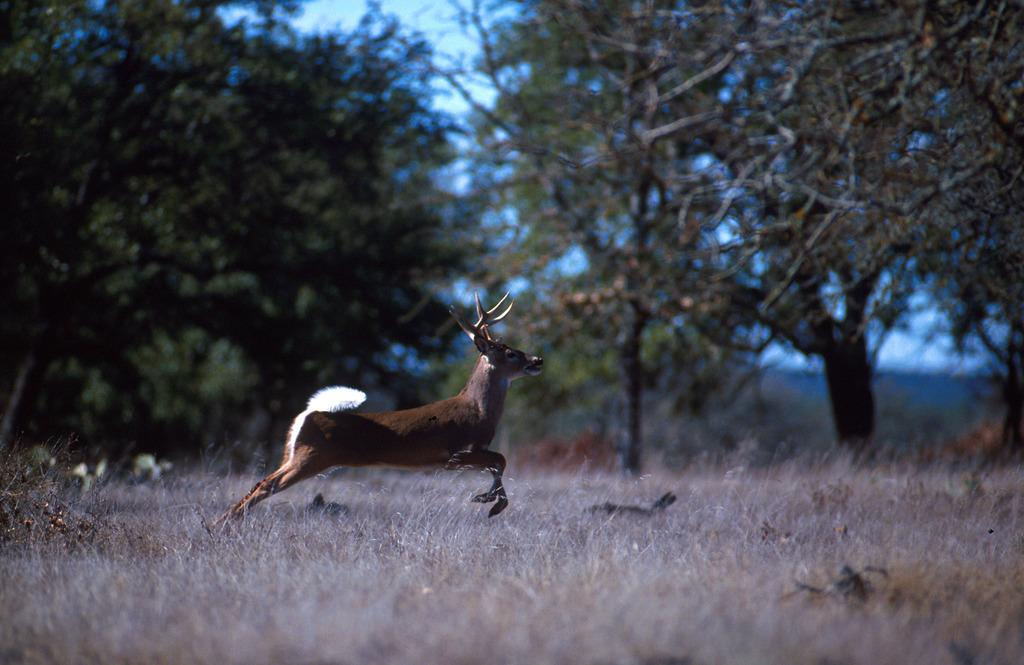What animal can be seen in the picture? There is a deer in the picture. What type of vegetation is present in the picture? There is grass in the picture. What can be seen in the background of the picture? There are trees and the sky visible in the background of the picture. What is the visitor's opinion on the soap in the picture? There is no visitor or soap present in the picture, so it is not possible to answer that question. 